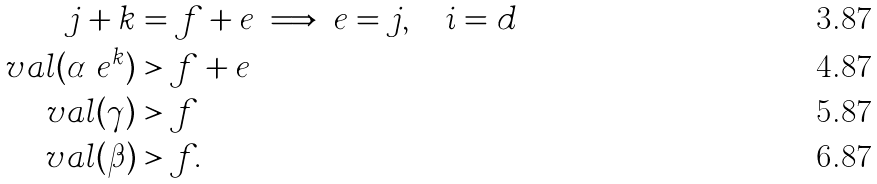Convert formula to latex. <formula><loc_0><loc_0><loc_500><loc_500>j + k & = f + e \implies e = j , \quad i = d \\ \ v a l ( \alpha \ e ^ { k } ) & > f + e \\ \ v a l ( \gamma ) & > f \\ \ v a l ( \beta ) & > f .</formula> 